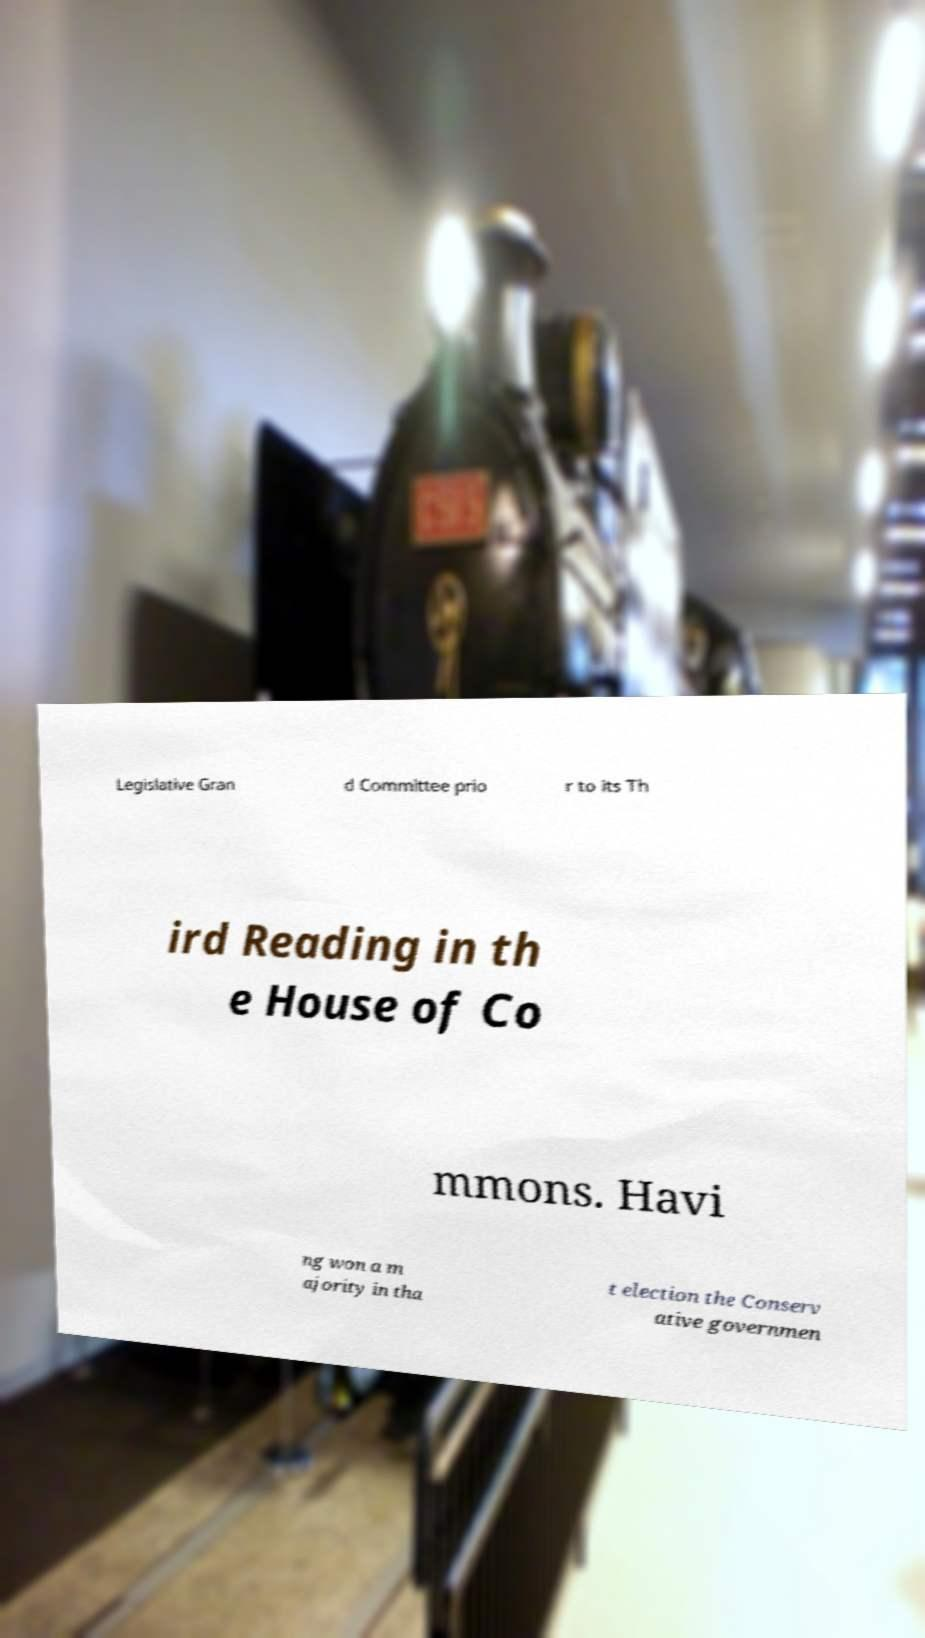What messages or text are displayed in this image? I need them in a readable, typed format. Legislative Gran d Committee prio r to its Th ird Reading in th e House of Co mmons. Havi ng won a m ajority in tha t election the Conserv ative governmen 